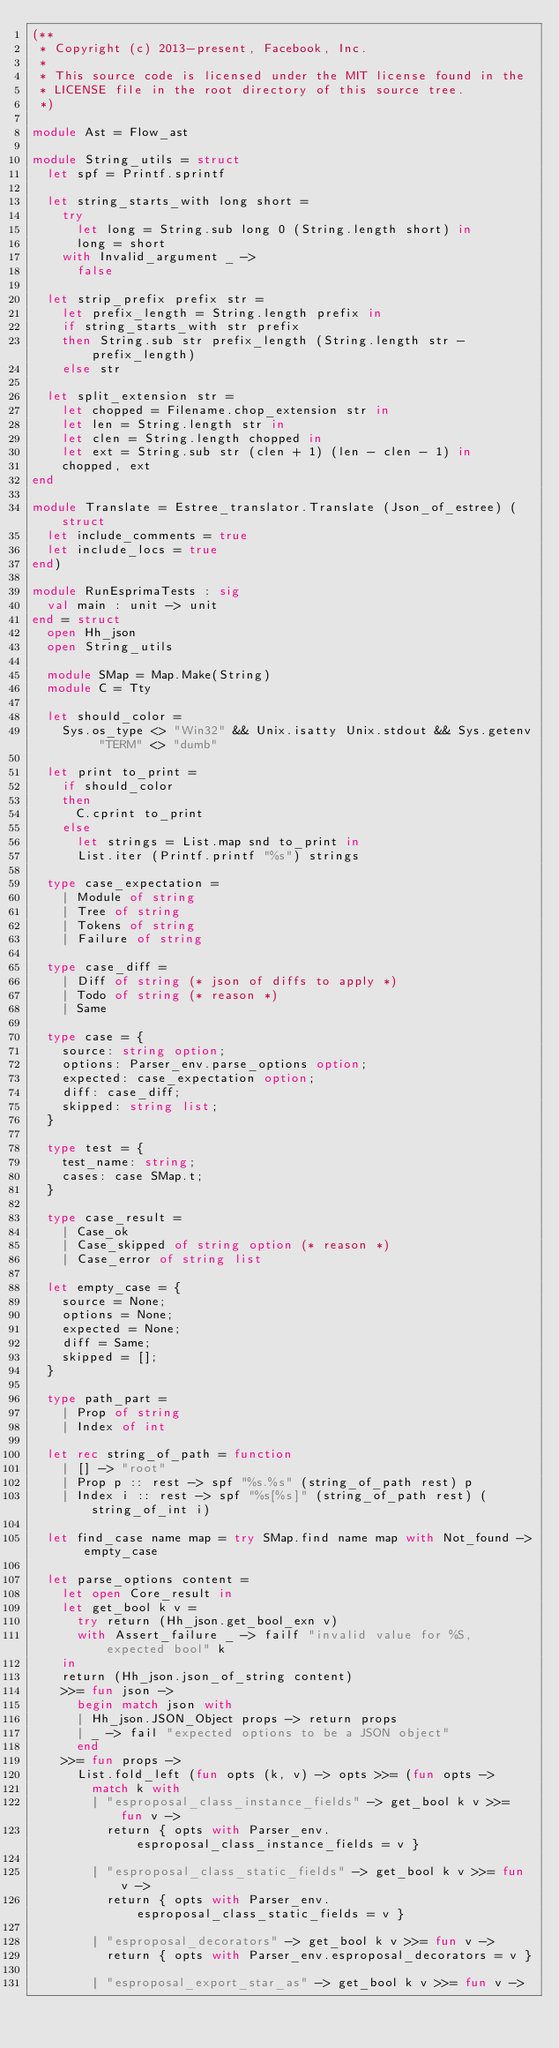Convert code to text. <code><loc_0><loc_0><loc_500><loc_500><_OCaml_>(**
 * Copyright (c) 2013-present, Facebook, Inc.
 *
 * This source code is licensed under the MIT license found in the
 * LICENSE file in the root directory of this source tree.
 *)

module Ast = Flow_ast

module String_utils = struct
  let spf = Printf.sprintf

  let string_starts_with long short =
    try
      let long = String.sub long 0 (String.length short) in
      long = short
    with Invalid_argument _ ->
      false

  let strip_prefix prefix str =
    let prefix_length = String.length prefix in
    if string_starts_with str prefix
    then String.sub str prefix_length (String.length str - prefix_length)
    else str

  let split_extension str =
    let chopped = Filename.chop_extension str in
    let len = String.length str in
    let clen = String.length chopped in
    let ext = String.sub str (clen + 1) (len - clen - 1) in
    chopped, ext
end

module Translate = Estree_translator.Translate (Json_of_estree) (struct
  let include_comments = true
  let include_locs = true
end)

module RunEsprimaTests : sig
  val main : unit -> unit
end = struct
  open Hh_json
  open String_utils

  module SMap = Map.Make(String)
  module C = Tty

  let should_color =
    Sys.os_type <> "Win32" && Unix.isatty Unix.stdout && Sys.getenv "TERM" <> "dumb"

  let print to_print =
    if should_color
    then
      C.cprint to_print
    else
      let strings = List.map snd to_print in
      List.iter (Printf.printf "%s") strings

  type case_expectation =
    | Module of string
    | Tree of string
    | Tokens of string
    | Failure of string

  type case_diff =
    | Diff of string (* json of diffs to apply *)
    | Todo of string (* reason *)
    | Same

  type case = {
    source: string option;
    options: Parser_env.parse_options option;
    expected: case_expectation option;
    diff: case_diff;
    skipped: string list;
  }

  type test = {
    test_name: string;
    cases: case SMap.t;
  }

  type case_result =
    | Case_ok
    | Case_skipped of string option (* reason *)
    | Case_error of string list

  let empty_case = {
    source = None;
    options = None;
    expected = None;
    diff = Same;
    skipped = [];
  }

  type path_part =
    | Prop of string
    | Index of int

  let rec string_of_path = function
    | [] -> "root"
    | Prop p :: rest -> spf "%s.%s" (string_of_path rest) p
    | Index i :: rest -> spf "%s[%s]" (string_of_path rest) (string_of_int i)

  let find_case name map = try SMap.find name map with Not_found -> empty_case

  let parse_options content =
    let open Core_result in
    let get_bool k v =
      try return (Hh_json.get_bool_exn v)
      with Assert_failure _ -> failf "invalid value for %S, expected bool" k
    in
    return (Hh_json.json_of_string content)
    >>= fun json ->
      begin match json with
      | Hh_json.JSON_Object props -> return props
      | _ -> fail "expected options to be a JSON object"
      end
    >>= fun props ->
      List.fold_left (fun opts (k, v) -> opts >>= (fun opts ->
        match k with
        | "esproposal_class_instance_fields" -> get_bool k v >>= fun v ->
          return { opts with Parser_env.esproposal_class_instance_fields = v }

        | "esproposal_class_static_fields" -> get_bool k v >>= fun v ->
          return { opts with Parser_env.esproposal_class_static_fields = v }

        | "esproposal_decorators" -> get_bool k v >>= fun v ->
          return { opts with Parser_env.esproposal_decorators = v }

        | "esproposal_export_star_as" -> get_bool k v >>= fun v -></code> 